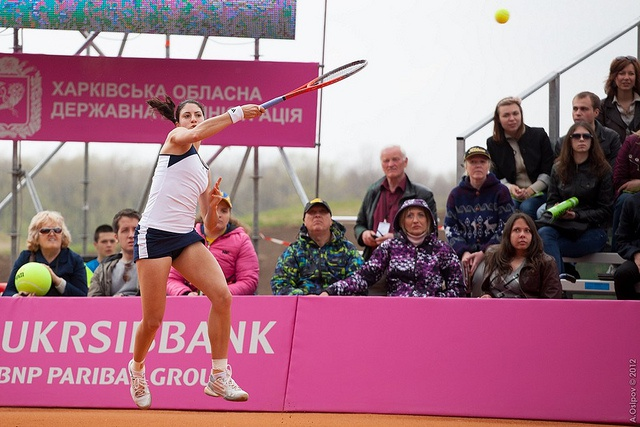Describe the objects in this image and their specific colors. I can see people in violet, lavender, brown, and lightpink tones, people in violet, black, purple, and maroon tones, people in violet, black, maroon, and brown tones, people in violet, black, gray, brown, and maroon tones, and people in violet, black, gray, navy, and brown tones in this image. 